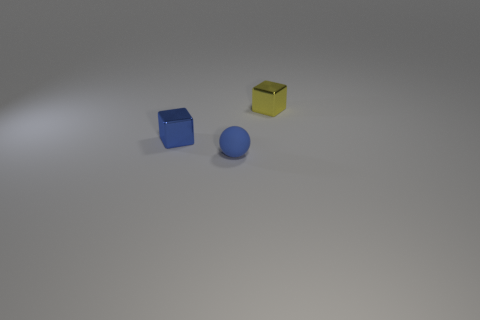Add 1 matte objects. How many objects exist? 4 Subtract all cubes. How many objects are left? 1 Subtract all tiny yellow objects. Subtract all metal cubes. How many objects are left? 0 Add 2 blue spheres. How many blue spheres are left? 3 Add 2 small red cylinders. How many small red cylinders exist? 2 Subtract 0 brown balls. How many objects are left? 3 